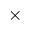<formula> <loc_0><loc_0><loc_500><loc_500>\times</formula> 